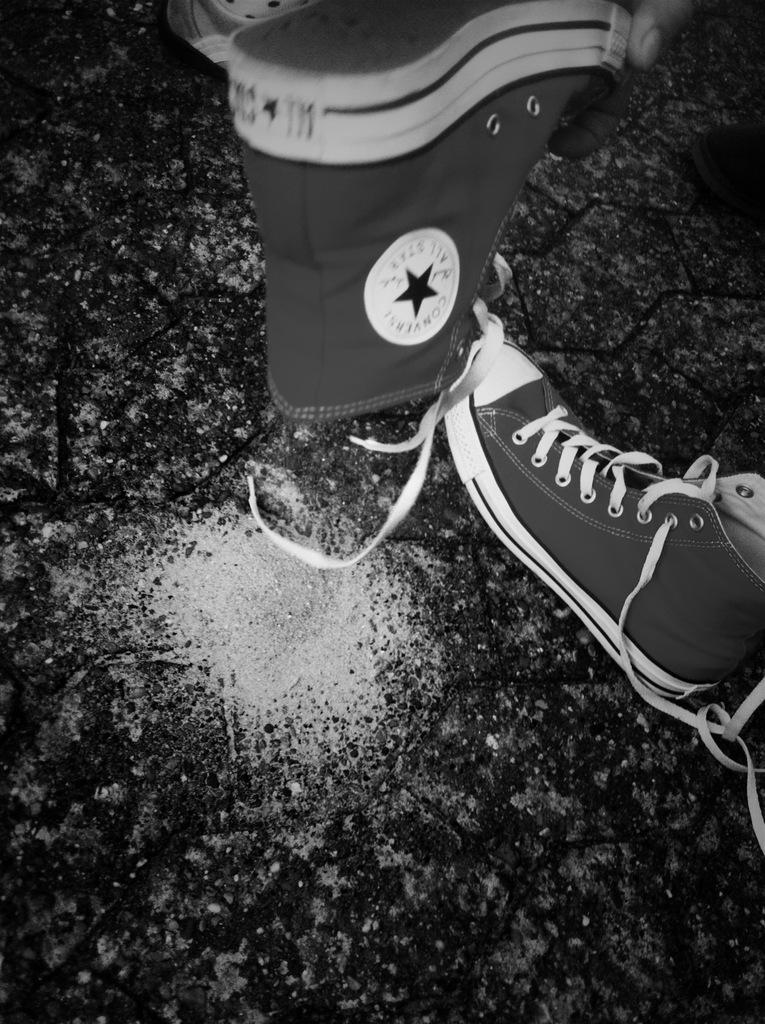What is the color scheme of the image? The image is black and white. What objects can be seen in the image? There are two shoes in the image. Can you tell me how many times the aunt jumps in the image? There is no aunt present in the image, and therefore no jumping can be observed. What type of cork is used to hold the shoes together in the image? There is no cork present in the image, and the shoes are not held together. 